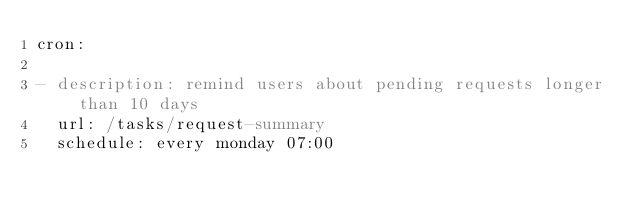<code> <loc_0><loc_0><loc_500><loc_500><_YAML_>cron:

- description: remind users about pending requests longer than 10 days
  url: /tasks/request-summary
  schedule: every monday 07:00</code> 